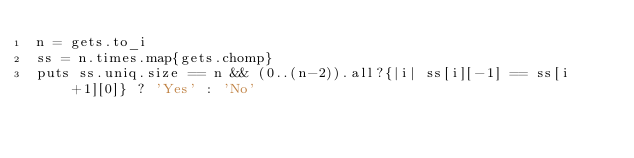<code> <loc_0><loc_0><loc_500><loc_500><_Ruby_>n = gets.to_i
ss = n.times.map{gets.chomp}
puts ss.uniq.size == n && (0..(n-2)).all?{|i| ss[i][-1] == ss[i+1][0]} ? 'Yes' : 'No'
</code> 